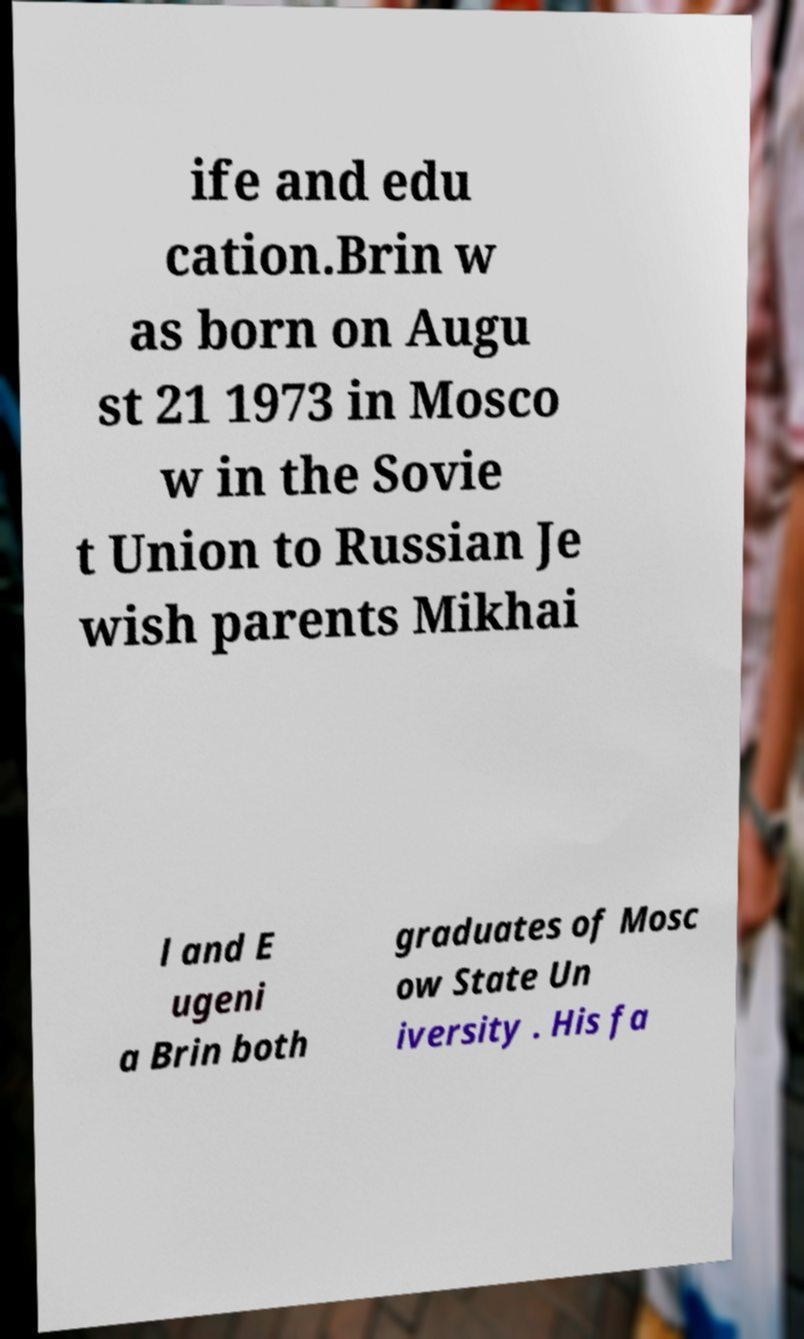For documentation purposes, I need the text within this image transcribed. Could you provide that? ife and edu cation.Brin w as born on Augu st 21 1973 in Mosco w in the Sovie t Union to Russian Je wish parents Mikhai l and E ugeni a Brin both graduates of Mosc ow State Un iversity . His fa 